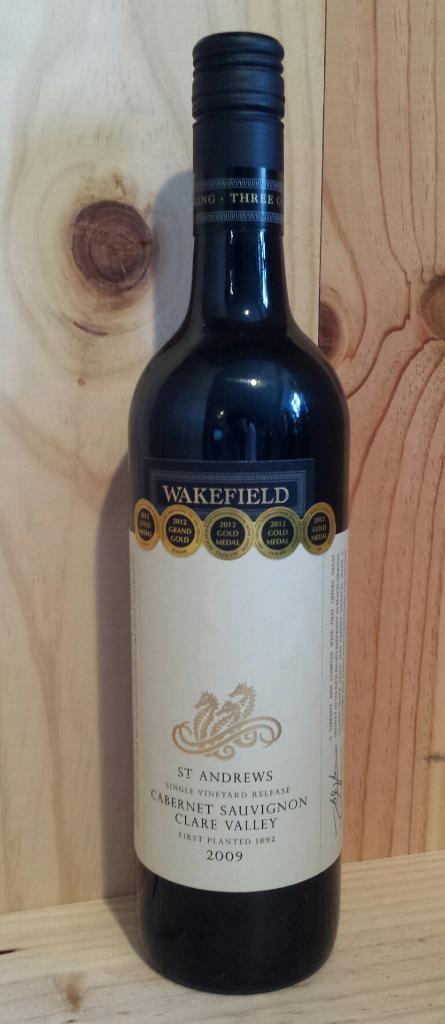Who makes this wine?
Offer a terse response. Wakefield. 